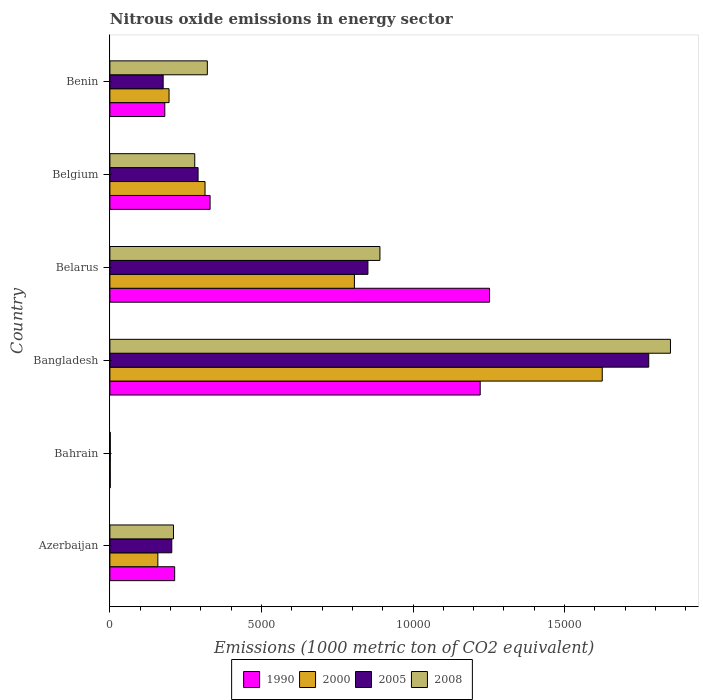How many groups of bars are there?
Provide a short and direct response. 6. Are the number of bars per tick equal to the number of legend labels?
Keep it short and to the point. Yes. Are the number of bars on each tick of the Y-axis equal?
Provide a succinct answer. Yes. What is the label of the 2nd group of bars from the top?
Offer a terse response. Belgium. In how many cases, is the number of bars for a given country not equal to the number of legend labels?
Your response must be concise. 0. What is the amount of nitrous oxide emitted in 2000 in Benin?
Make the answer very short. 1951.3. Across all countries, what is the maximum amount of nitrous oxide emitted in 2008?
Your answer should be compact. 1.85e+04. In which country was the amount of nitrous oxide emitted in 2005 minimum?
Provide a succinct answer. Bahrain. What is the total amount of nitrous oxide emitted in 2005 in the graph?
Make the answer very short. 3.30e+04. What is the difference between the amount of nitrous oxide emitted in 2008 in Bangladesh and that in Benin?
Give a very brief answer. 1.53e+04. What is the difference between the amount of nitrous oxide emitted in 2000 in Belarus and the amount of nitrous oxide emitted in 2008 in Benin?
Offer a very short reply. 4851.4. What is the average amount of nitrous oxide emitted in 2000 per country?
Your answer should be very brief. 5165.37. What is the difference between the amount of nitrous oxide emitted in 2000 and amount of nitrous oxide emitted in 2005 in Bangladesh?
Keep it short and to the point. -1533.4. What is the ratio of the amount of nitrous oxide emitted in 2008 in Azerbaijan to that in Bangladesh?
Provide a succinct answer. 0.11. Is the amount of nitrous oxide emitted in 2005 in Azerbaijan less than that in Bangladesh?
Keep it short and to the point. Yes. Is the difference between the amount of nitrous oxide emitted in 2000 in Bangladesh and Belarus greater than the difference between the amount of nitrous oxide emitted in 2005 in Bangladesh and Belarus?
Offer a very short reply. No. What is the difference between the highest and the second highest amount of nitrous oxide emitted in 2005?
Your answer should be compact. 9263.9. What is the difference between the highest and the lowest amount of nitrous oxide emitted in 2000?
Your answer should be compact. 1.62e+04. In how many countries, is the amount of nitrous oxide emitted in 1990 greater than the average amount of nitrous oxide emitted in 1990 taken over all countries?
Your answer should be compact. 2. What does the 3rd bar from the bottom in Azerbaijan represents?
Ensure brevity in your answer.  2005. How many countries are there in the graph?
Provide a short and direct response. 6. Does the graph contain any zero values?
Offer a very short reply. No. Does the graph contain grids?
Offer a terse response. No. Where does the legend appear in the graph?
Your response must be concise. Bottom center. How are the legend labels stacked?
Make the answer very short. Horizontal. What is the title of the graph?
Keep it short and to the point. Nitrous oxide emissions in energy sector. What is the label or title of the X-axis?
Give a very brief answer. Emissions (1000 metric ton of CO2 equivalent). What is the Emissions (1000 metric ton of CO2 equivalent) of 1990 in Azerbaijan?
Provide a short and direct response. 2137.1. What is the Emissions (1000 metric ton of CO2 equivalent) of 2000 in Azerbaijan?
Make the answer very short. 1582.1. What is the Emissions (1000 metric ton of CO2 equivalent) of 2005 in Azerbaijan?
Offer a very short reply. 2041.5. What is the Emissions (1000 metric ton of CO2 equivalent) in 2008 in Azerbaijan?
Provide a succinct answer. 2098. What is the Emissions (1000 metric ton of CO2 equivalent) of 2005 in Bahrain?
Offer a very short reply. 13.1. What is the Emissions (1000 metric ton of CO2 equivalent) in 1990 in Bangladesh?
Give a very brief answer. 1.22e+04. What is the Emissions (1000 metric ton of CO2 equivalent) in 2000 in Bangladesh?
Offer a terse response. 1.62e+04. What is the Emissions (1000 metric ton of CO2 equivalent) of 2005 in Bangladesh?
Offer a terse response. 1.78e+04. What is the Emissions (1000 metric ton of CO2 equivalent) in 2008 in Bangladesh?
Offer a terse response. 1.85e+04. What is the Emissions (1000 metric ton of CO2 equivalent) in 1990 in Belarus?
Provide a short and direct response. 1.25e+04. What is the Emissions (1000 metric ton of CO2 equivalent) of 2000 in Belarus?
Make the answer very short. 8066.2. What is the Emissions (1000 metric ton of CO2 equivalent) in 2005 in Belarus?
Your answer should be compact. 8511.9. What is the Emissions (1000 metric ton of CO2 equivalent) in 2008 in Belarus?
Provide a short and direct response. 8908.4. What is the Emissions (1000 metric ton of CO2 equivalent) in 1990 in Belgium?
Offer a very short reply. 3305.4. What is the Emissions (1000 metric ton of CO2 equivalent) in 2000 in Belgium?
Give a very brief answer. 3138.4. What is the Emissions (1000 metric ton of CO2 equivalent) of 2005 in Belgium?
Your answer should be very brief. 2909.4. What is the Emissions (1000 metric ton of CO2 equivalent) of 2008 in Belgium?
Give a very brief answer. 2799.3. What is the Emissions (1000 metric ton of CO2 equivalent) in 1990 in Benin?
Make the answer very short. 1811.1. What is the Emissions (1000 metric ton of CO2 equivalent) of 2000 in Benin?
Ensure brevity in your answer.  1951.3. What is the Emissions (1000 metric ton of CO2 equivalent) of 2005 in Benin?
Provide a succinct answer. 1757.4. What is the Emissions (1000 metric ton of CO2 equivalent) of 2008 in Benin?
Keep it short and to the point. 3214.8. Across all countries, what is the maximum Emissions (1000 metric ton of CO2 equivalent) in 1990?
Make the answer very short. 1.25e+04. Across all countries, what is the maximum Emissions (1000 metric ton of CO2 equivalent) in 2000?
Give a very brief answer. 1.62e+04. Across all countries, what is the maximum Emissions (1000 metric ton of CO2 equivalent) of 2005?
Your answer should be very brief. 1.78e+04. Across all countries, what is the maximum Emissions (1000 metric ton of CO2 equivalent) in 2008?
Your response must be concise. 1.85e+04. Across all countries, what is the minimum Emissions (1000 metric ton of CO2 equivalent) of 2000?
Your response must be concise. 11.8. Across all countries, what is the minimum Emissions (1000 metric ton of CO2 equivalent) in 2005?
Ensure brevity in your answer.  13.1. Across all countries, what is the minimum Emissions (1000 metric ton of CO2 equivalent) of 2008?
Provide a short and direct response. 13.6. What is the total Emissions (1000 metric ton of CO2 equivalent) of 1990 in the graph?
Make the answer very short. 3.20e+04. What is the total Emissions (1000 metric ton of CO2 equivalent) of 2000 in the graph?
Your answer should be compact. 3.10e+04. What is the total Emissions (1000 metric ton of CO2 equivalent) in 2005 in the graph?
Keep it short and to the point. 3.30e+04. What is the total Emissions (1000 metric ton of CO2 equivalent) of 2008 in the graph?
Offer a terse response. 3.55e+04. What is the difference between the Emissions (1000 metric ton of CO2 equivalent) of 1990 in Azerbaijan and that in Bahrain?
Ensure brevity in your answer.  2124.6. What is the difference between the Emissions (1000 metric ton of CO2 equivalent) in 2000 in Azerbaijan and that in Bahrain?
Offer a terse response. 1570.3. What is the difference between the Emissions (1000 metric ton of CO2 equivalent) of 2005 in Azerbaijan and that in Bahrain?
Provide a short and direct response. 2028.4. What is the difference between the Emissions (1000 metric ton of CO2 equivalent) in 2008 in Azerbaijan and that in Bahrain?
Ensure brevity in your answer.  2084.4. What is the difference between the Emissions (1000 metric ton of CO2 equivalent) of 1990 in Azerbaijan and that in Bangladesh?
Offer a very short reply. -1.01e+04. What is the difference between the Emissions (1000 metric ton of CO2 equivalent) of 2000 in Azerbaijan and that in Bangladesh?
Provide a succinct answer. -1.47e+04. What is the difference between the Emissions (1000 metric ton of CO2 equivalent) in 2005 in Azerbaijan and that in Bangladesh?
Provide a succinct answer. -1.57e+04. What is the difference between the Emissions (1000 metric ton of CO2 equivalent) in 2008 in Azerbaijan and that in Bangladesh?
Ensure brevity in your answer.  -1.64e+04. What is the difference between the Emissions (1000 metric ton of CO2 equivalent) in 1990 in Azerbaijan and that in Belarus?
Give a very brief answer. -1.04e+04. What is the difference between the Emissions (1000 metric ton of CO2 equivalent) of 2000 in Azerbaijan and that in Belarus?
Offer a very short reply. -6484.1. What is the difference between the Emissions (1000 metric ton of CO2 equivalent) in 2005 in Azerbaijan and that in Belarus?
Make the answer very short. -6470.4. What is the difference between the Emissions (1000 metric ton of CO2 equivalent) of 2008 in Azerbaijan and that in Belarus?
Your answer should be compact. -6810.4. What is the difference between the Emissions (1000 metric ton of CO2 equivalent) in 1990 in Azerbaijan and that in Belgium?
Offer a terse response. -1168.3. What is the difference between the Emissions (1000 metric ton of CO2 equivalent) of 2000 in Azerbaijan and that in Belgium?
Make the answer very short. -1556.3. What is the difference between the Emissions (1000 metric ton of CO2 equivalent) of 2005 in Azerbaijan and that in Belgium?
Your answer should be compact. -867.9. What is the difference between the Emissions (1000 metric ton of CO2 equivalent) in 2008 in Azerbaijan and that in Belgium?
Provide a short and direct response. -701.3. What is the difference between the Emissions (1000 metric ton of CO2 equivalent) of 1990 in Azerbaijan and that in Benin?
Make the answer very short. 326. What is the difference between the Emissions (1000 metric ton of CO2 equivalent) in 2000 in Azerbaijan and that in Benin?
Your answer should be very brief. -369.2. What is the difference between the Emissions (1000 metric ton of CO2 equivalent) in 2005 in Azerbaijan and that in Benin?
Provide a short and direct response. 284.1. What is the difference between the Emissions (1000 metric ton of CO2 equivalent) of 2008 in Azerbaijan and that in Benin?
Make the answer very short. -1116.8. What is the difference between the Emissions (1000 metric ton of CO2 equivalent) of 1990 in Bahrain and that in Bangladesh?
Give a very brief answer. -1.22e+04. What is the difference between the Emissions (1000 metric ton of CO2 equivalent) of 2000 in Bahrain and that in Bangladesh?
Ensure brevity in your answer.  -1.62e+04. What is the difference between the Emissions (1000 metric ton of CO2 equivalent) of 2005 in Bahrain and that in Bangladesh?
Provide a short and direct response. -1.78e+04. What is the difference between the Emissions (1000 metric ton of CO2 equivalent) in 2008 in Bahrain and that in Bangladesh?
Offer a terse response. -1.85e+04. What is the difference between the Emissions (1000 metric ton of CO2 equivalent) of 1990 in Bahrain and that in Belarus?
Ensure brevity in your answer.  -1.25e+04. What is the difference between the Emissions (1000 metric ton of CO2 equivalent) of 2000 in Bahrain and that in Belarus?
Provide a short and direct response. -8054.4. What is the difference between the Emissions (1000 metric ton of CO2 equivalent) of 2005 in Bahrain and that in Belarus?
Keep it short and to the point. -8498.8. What is the difference between the Emissions (1000 metric ton of CO2 equivalent) in 2008 in Bahrain and that in Belarus?
Provide a short and direct response. -8894.8. What is the difference between the Emissions (1000 metric ton of CO2 equivalent) in 1990 in Bahrain and that in Belgium?
Ensure brevity in your answer.  -3292.9. What is the difference between the Emissions (1000 metric ton of CO2 equivalent) of 2000 in Bahrain and that in Belgium?
Offer a terse response. -3126.6. What is the difference between the Emissions (1000 metric ton of CO2 equivalent) in 2005 in Bahrain and that in Belgium?
Ensure brevity in your answer.  -2896.3. What is the difference between the Emissions (1000 metric ton of CO2 equivalent) in 2008 in Bahrain and that in Belgium?
Your answer should be compact. -2785.7. What is the difference between the Emissions (1000 metric ton of CO2 equivalent) of 1990 in Bahrain and that in Benin?
Keep it short and to the point. -1798.6. What is the difference between the Emissions (1000 metric ton of CO2 equivalent) in 2000 in Bahrain and that in Benin?
Keep it short and to the point. -1939.5. What is the difference between the Emissions (1000 metric ton of CO2 equivalent) in 2005 in Bahrain and that in Benin?
Offer a very short reply. -1744.3. What is the difference between the Emissions (1000 metric ton of CO2 equivalent) of 2008 in Bahrain and that in Benin?
Your answer should be very brief. -3201.2. What is the difference between the Emissions (1000 metric ton of CO2 equivalent) in 1990 in Bangladesh and that in Belarus?
Give a very brief answer. -308.3. What is the difference between the Emissions (1000 metric ton of CO2 equivalent) in 2000 in Bangladesh and that in Belarus?
Your response must be concise. 8176.2. What is the difference between the Emissions (1000 metric ton of CO2 equivalent) in 2005 in Bangladesh and that in Belarus?
Keep it short and to the point. 9263.9. What is the difference between the Emissions (1000 metric ton of CO2 equivalent) in 2008 in Bangladesh and that in Belarus?
Offer a terse response. 9584.1. What is the difference between the Emissions (1000 metric ton of CO2 equivalent) in 1990 in Bangladesh and that in Belgium?
Give a very brief answer. 8910.9. What is the difference between the Emissions (1000 metric ton of CO2 equivalent) in 2000 in Bangladesh and that in Belgium?
Keep it short and to the point. 1.31e+04. What is the difference between the Emissions (1000 metric ton of CO2 equivalent) of 2005 in Bangladesh and that in Belgium?
Offer a terse response. 1.49e+04. What is the difference between the Emissions (1000 metric ton of CO2 equivalent) of 2008 in Bangladesh and that in Belgium?
Your response must be concise. 1.57e+04. What is the difference between the Emissions (1000 metric ton of CO2 equivalent) of 1990 in Bangladesh and that in Benin?
Your answer should be compact. 1.04e+04. What is the difference between the Emissions (1000 metric ton of CO2 equivalent) of 2000 in Bangladesh and that in Benin?
Provide a succinct answer. 1.43e+04. What is the difference between the Emissions (1000 metric ton of CO2 equivalent) of 2005 in Bangladesh and that in Benin?
Provide a short and direct response. 1.60e+04. What is the difference between the Emissions (1000 metric ton of CO2 equivalent) of 2008 in Bangladesh and that in Benin?
Your answer should be compact. 1.53e+04. What is the difference between the Emissions (1000 metric ton of CO2 equivalent) of 1990 in Belarus and that in Belgium?
Offer a very short reply. 9219.2. What is the difference between the Emissions (1000 metric ton of CO2 equivalent) of 2000 in Belarus and that in Belgium?
Offer a very short reply. 4927.8. What is the difference between the Emissions (1000 metric ton of CO2 equivalent) of 2005 in Belarus and that in Belgium?
Offer a terse response. 5602.5. What is the difference between the Emissions (1000 metric ton of CO2 equivalent) of 2008 in Belarus and that in Belgium?
Your answer should be compact. 6109.1. What is the difference between the Emissions (1000 metric ton of CO2 equivalent) of 1990 in Belarus and that in Benin?
Your response must be concise. 1.07e+04. What is the difference between the Emissions (1000 metric ton of CO2 equivalent) in 2000 in Belarus and that in Benin?
Make the answer very short. 6114.9. What is the difference between the Emissions (1000 metric ton of CO2 equivalent) in 2005 in Belarus and that in Benin?
Give a very brief answer. 6754.5. What is the difference between the Emissions (1000 metric ton of CO2 equivalent) of 2008 in Belarus and that in Benin?
Give a very brief answer. 5693.6. What is the difference between the Emissions (1000 metric ton of CO2 equivalent) in 1990 in Belgium and that in Benin?
Your response must be concise. 1494.3. What is the difference between the Emissions (1000 metric ton of CO2 equivalent) of 2000 in Belgium and that in Benin?
Ensure brevity in your answer.  1187.1. What is the difference between the Emissions (1000 metric ton of CO2 equivalent) in 2005 in Belgium and that in Benin?
Ensure brevity in your answer.  1152. What is the difference between the Emissions (1000 metric ton of CO2 equivalent) of 2008 in Belgium and that in Benin?
Give a very brief answer. -415.5. What is the difference between the Emissions (1000 metric ton of CO2 equivalent) of 1990 in Azerbaijan and the Emissions (1000 metric ton of CO2 equivalent) of 2000 in Bahrain?
Keep it short and to the point. 2125.3. What is the difference between the Emissions (1000 metric ton of CO2 equivalent) in 1990 in Azerbaijan and the Emissions (1000 metric ton of CO2 equivalent) in 2005 in Bahrain?
Keep it short and to the point. 2124. What is the difference between the Emissions (1000 metric ton of CO2 equivalent) in 1990 in Azerbaijan and the Emissions (1000 metric ton of CO2 equivalent) in 2008 in Bahrain?
Offer a very short reply. 2123.5. What is the difference between the Emissions (1000 metric ton of CO2 equivalent) of 2000 in Azerbaijan and the Emissions (1000 metric ton of CO2 equivalent) of 2005 in Bahrain?
Keep it short and to the point. 1569. What is the difference between the Emissions (1000 metric ton of CO2 equivalent) of 2000 in Azerbaijan and the Emissions (1000 metric ton of CO2 equivalent) of 2008 in Bahrain?
Ensure brevity in your answer.  1568.5. What is the difference between the Emissions (1000 metric ton of CO2 equivalent) of 2005 in Azerbaijan and the Emissions (1000 metric ton of CO2 equivalent) of 2008 in Bahrain?
Keep it short and to the point. 2027.9. What is the difference between the Emissions (1000 metric ton of CO2 equivalent) in 1990 in Azerbaijan and the Emissions (1000 metric ton of CO2 equivalent) in 2000 in Bangladesh?
Provide a succinct answer. -1.41e+04. What is the difference between the Emissions (1000 metric ton of CO2 equivalent) in 1990 in Azerbaijan and the Emissions (1000 metric ton of CO2 equivalent) in 2005 in Bangladesh?
Provide a short and direct response. -1.56e+04. What is the difference between the Emissions (1000 metric ton of CO2 equivalent) in 1990 in Azerbaijan and the Emissions (1000 metric ton of CO2 equivalent) in 2008 in Bangladesh?
Keep it short and to the point. -1.64e+04. What is the difference between the Emissions (1000 metric ton of CO2 equivalent) of 2000 in Azerbaijan and the Emissions (1000 metric ton of CO2 equivalent) of 2005 in Bangladesh?
Your answer should be compact. -1.62e+04. What is the difference between the Emissions (1000 metric ton of CO2 equivalent) in 2000 in Azerbaijan and the Emissions (1000 metric ton of CO2 equivalent) in 2008 in Bangladesh?
Provide a succinct answer. -1.69e+04. What is the difference between the Emissions (1000 metric ton of CO2 equivalent) of 2005 in Azerbaijan and the Emissions (1000 metric ton of CO2 equivalent) of 2008 in Bangladesh?
Your answer should be compact. -1.65e+04. What is the difference between the Emissions (1000 metric ton of CO2 equivalent) of 1990 in Azerbaijan and the Emissions (1000 metric ton of CO2 equivalent) of 2000 in Belarus?
Keep it short and to the point. -5929.1. What is the difference between the Emissions (1000 metric ton of CO2 equivalent) in 1990 in Azerbaijan and the Emissions (1000 metric ton of CO2 equivalent) in 2005 in Belarus?
Provide a succinct answer. -6374.8. What is the difference between the Emissions (1000 metric ton of CO2 equivalent) in 1990 in Azerbaijan and the Emissions (1000 metric ton of CO2 equivalent) in 2008 in Belarus?
Ensure brevity in your answer.  -6771.3. What is the difference between the Emissions (1000 metric ton of CO2 equivalent) of 2000 in Azerbaijan and the Emissions (1000 metric ton of CO2 equivalent) of 2005 in Belarus?
Provide a short and direct response. -6929.8. What is the difference between the Emissions (1000 metric ton of CO2 equivalent) of 2000 in Azerbaijan and the Emissions (1000 metric ton of CO2 equivalent) of 2008 in Belarus?
Provide a succinct answer. -7326.3. What is the difference between the Emissions (1000 metric ton of CO2 equivalent) in 2005 in Azerbaijan and the Emissions (1000 metric ton of CO2 equivalent) in 2008 in Belarus?
Keep it short and to the point. -6866.9. What is the difference between the Emissions (1000 metric ton of CO2 equivalent) in 1990 in Azerbaijan and the Emissions (1000 metric ton of CO2 equivalent) in 2000 in Belgium?
Offer a terse response. -1001.3. What is the difference between the Emissions (1000 metric ton of CO2 equivalent) in 1990 in Azerbaijan and the Emissions (1000 metric ton of CO2 equivalent) in 2005 in Belgium?
Ensure brevity in your answer.  -772.3. What is the difference between the Emissions (1000 metric ton of CO2 equivalent) in 1990 in Azerbaijan and the Emissions (1000 metric ton of CO2 equivalent) in 2008 in Belgium?
Ensure brevity in your answer.  -662.2. What is the difference between the Emissions (1000 metric ton of CO2 equivalent) in 2000 in Azerbaijan and the Emissions (1000 metric ton of CO2 equivalent) in 2005 in Belgium?
Offer a terse response. -1327.3. What is the difference between the Emissions (1000 metric ton of CO2 equivalent) in 2000 in Azerbaijan and the Emissions (1000 metric ton of CO2 equivalent) in 2008 in Belgium?
Keep it short and to the point. -1217.2. What is the difference between the Emissions (1000 metric ton of CO2 equivalent) in 2005 in Azerbaijan and the Emissions (1000 metric ton of CO2 equivalent) in 2008 in Belgium?
Offer a terse response. -757.8. What is the difference between the Emissions (1000 metric ton of CO2 equivalent) in 1990 in Azerbaijan and the Emissions (1000 metric ton of CO2 equivalent) in 2000 in Benin?
Make the answer very short. 185.8. What is the difference between the Emissions (1000 metric ton of CO2 equivalent) of 1990 in Azerbaijan and the Emissions (1000 metric ton of CO2 equivalent) of 2005 in Benin?
Ensure brevity in your answer.  379.7. What is the difference between the Emissions (1000 metric ton of CO2 equivalent) of 1990 in Azerbaijan and the Emissions (1000 metric ton of CO2 equivalent) of 2008 in Benin?
Provide a short and direct response. -1077.7. What is the difference between the Emissions (1000 metric ton of CO2 equivalent) in 2000 in Azerbaijan and the Emissions (1000 metric ton of CO2 equivalent) in 2005 in Benin?
Make the answer very short. -175.3. What is the difference between the Emissions (1000 metric ton of CO2 equivalent) in 2000 in Azerbaijan and the Emissions (1000 metric ton of CO2 equivalent) in 2008 in Benin?
Keep it short and to the point. -1632.7. What is the difference between the Emissions (1000 metric ton of CO2 equivalent) in 2005 in Azerbaijan and the Emissions (1000 metric ton of CO2 equivalent) in 2008 in Benin?
Your answer should be compact. -1173.3. What is the difference between the Emissions (1000 metric ton of CO2 equivalent) in 1990 in Bahrain and the Emissions (1000 metric ton of CO2 equivalent) in 2000 in Bangladesh?
Ensure brevity in your answer.  -1.62e+04. What is the difference between the Emissions (1000 metric ton of CO2 equivalent) of 1990 in Bahrain and the Emissions (1000 metric ton of CO2 equivalent) of 2005 in Bangladesh?
Give a very brief answer. -1.78e+04. What is the difference between the Emissions (1000 metric ton of CO2 equivalent) of 1990 in Bahrain and the Emissions (1000 metric ton of CO2 equivalent) of 2008 in Bangladesh?
Provide a short and direct response. -1.85e+04. What is the difference between the Emissions (1000 metric ton of CO2 equivalent) of 2000 in Bahrain and the Emissions (1000 metric ton of CO2 equivalent) of 2005 in Bangladesh?
Make the answer very short. -1.78e+04. What is the difference between the Emissions (1000 metric ton of CO2 equivalent) of 2000 in Bahrain and the Emissions (1000 metric ton of CO2 equivalent) of 2008 in Bangladesh?
Provide a succinct answer. -1.85e+04. What is the difference between the Emissions (1000 metric ton of CO2 equivalent) of 2005 in Bahrain and the Emissions (1000 metric ton of CO2 equivalent) of 2008 in Bangladesh?
Keep it short and to the point. -1.85e+04. What is the difference between the Emissions (1000 metric ton of CO2 equivalent) of 1990 in Bahrain and the Emissions (1000 metric ton of CO2 equivalent) of 2000 in Belarus?
Make the answer very short. -8053.7. What is the difference between the Emissions (1000 metric ton of CO2 equivalent) in 1990 in Bahrain and the Emissions (1000 metric ton of CO2 equivalent) in 2005 in Belarus?
Your response must be concise. -8499.4. What is the difference between the Emissions (1000 metric ton of CO2 equivalent) in 1990 in Bahrain and the Emissions (1000 metric ton of CO2 equivalent) in 2008 in Belarus?
Your answer should be compact. -8895.9. What is the difference between the Emissions (1000 metric ton of CO2 equivalent) of 2000 in Bahrain and the Emissions (1000 metric ton of CO2 equivalent) of 2005 in Belarus?
Ensure brevity in your answer.  -8500.1. What is the difference between the Emissions (1000 metric ton of CO2 equivalent) of 2000 in Bahrain and the Emissions (1000 metric ton of CO2 equivalent) of 2008 in Belarus?
Make the answer very short. -8896.6. What is the difference between the Emissions (1000 metric ton of CO2 equivalent) in 2005 in Bahrain and the Emissions (1000 metric ton of CO2 equivalent) in 2008 in Belarus?
Provide a succinct answer. -8895.3. What is the difference between the Emissions (1000 metric ton of CO2 equivalent) in 1990 in Bahrain and the Emissions (1000 metric ton of CO2 equivalent) in 2000 in Belgium?
Make the answer very short. -3125.9. What is the difference between the Emissions (1000 metric ton of CO2 equivalent) in 1990 in Bahrain and the Emissions (1000 metric ton of CO2 equivalent) in 2005 in Belgium?
Your answer should be very brief. -2896.9. What is the difference between the Emissions (1000 metric ton of CO2 equivalent) in 1990 in Bahrain and the Emissions (1000 metric ton of CO2 equivalent) in 2008 in Belgium?
Ensure brevity in your answer.  -2786.8. What is the difference between the Emissions (1000 metric ton of CO2 equivalent) of 2000 in Bahrain and the Emissions (1000 metric ton of CO2 equivalent) of 2005 in Belgium?
Offer a very short reply. -2897.6. What is the difference between the Emissions (1000 metric ton of CO2 equivalent) of 2000 in Bahrain and the Emissions (1000 metric ton of CO2 equivalent) of 2008 in Belgium?
Keep it short and to the point. -2787.5. What is the difference between the Emissions (1000 metric ton of CO2 equivalent) in 2005 in Bahrain and the Emissions (1000 metric ton of CO2 equivalent) in 2008 in Belgium?
Provide a succinct answer. -2786.2. What is the difference between the Emissions (1000 metric ton of CO2 equivalent) in 1990 in Bahrain and the Emissions (1000 metric ton of CO2 equivalent) in 2000 in Benin?
Provide a succinct answer. -1938.8. What is the difference between the Emissions (1000 metric ton of CO2 equivalent) in 1990 in Bahrain and the Emissions (1000 metric ton of CO2 equivalent) in 2005 in Benin?
Give a very brief answer. -1744.9. What is the difference between the Emissions (1000 metric ton of CO2 equivalent) of 1990 in Bahrain and the Emissions (1000 metric ton of CO2 equivalent) of 2008 in Benin?
Provide a succinct answer. -3202.3. What is the difference between the Emissions (1000 metric ton of CO2 equivalent) of 2000 in Bahrain and the Emissions (1000 metric ton of CO2 equivalent) of 2005 in Benin?
Make the answer very short. -1745.6. What is the difference between the Emissions (1000 metric ton of CO2 equivalent) in 2000 in Bahrain and the Emissions (1000 metric ton of CO2 equivalent) in 2008 in Benin?
Offer a very short reply. -3203. What is the difference between the Emissions (1000 metric ton of CO2 equivalent) of 2005 in Bahrain and the Emissions (1000 metric ton of CO2 equivalent) of 2008 in Benin?
Your answer should be very brief. -3201.7. What is the difference between the Emissions (1000 metric ton of CO2 equivalent) of 1990 in Bangladesh and the Emissions (1000 metric ton of CO2 equivalent) of 2000 in Belarus?
Your response must be concise. 4150.1. What is the difference between the Emissions (1000 metric ton of CO2 equivalent) in 1990 in Bangladesh and the Emissions (1000 metric ton of CO2 equivalent) in 2005 in Belarus?
Make the answer very short. 3704.4. What is the difference between the Emissions (1000 metric ton of CO2 equivalent) of 1990 in Bangladesh and the Emissions (1000 metric ton of CO2 equivalent) of 2008 in Belarus?
Make the answer very short. 3307.9. What is the difference between the Emissions (1000 metric ton of CO2 equivalent) of 2000 in Bangladesh and the Emissions (1000 metric ton of CO2 equivalent) of 2005 in Belarus?
Your answer should be very brief. 7730.5. What is the difference between the Emissions (1000 metric ton of CO2 equivalent) in 2000 in Bangladesh and the Emissions (1000 metric ton of CO2 equivalent) in 2008 in Belarus?
Keep it short and to the point. 7334. What is the difference between the Emissions (1000 metric ton of CO2 equivalent) of 2005 in Bangladesh and the Emissions (1000 metric ton of CO2 equivalent) of 2008 in Belarus?
Provide a short and direct response. 8867.4. What is the difference between the Emissions (1000 metric ton of CO2 equivalent) of 1990 in Bangladesh and the Emissions (1000 metric ton of CO2 equivalent) of 2000 in Belgium?
Give a very brief answer. 9077.9. What is the difference between the Emissions (1000 metric ton of CO2 equivalent) in 1990 in Bangladesh and the Emissions (1000 metric ton of CO2 equivalent) in 2005 in Belgium?
Your answer should be very brief. 9306.9. What is the difference between the Emissions (1000 metric ton of CO2 equivalent) in 1990 in Bangladesh and the Emissions (1000 metric ton of CO2 equivalent) in 2008 in Belgium?
Provide a short and direct response. 9417. What is the difference between the Emissions (1000 metric ton of CO2 equivalent) in 2000 in Bangladesh and the Emissions (1000 metric ton of CO2 equivalent) in 2005 in Belgium?
Your answer should be very brief. 1.33e+04. What is the difference between the Emissions (1000 metric ton of CO2 equivalent) in 2000 in Bangladesh and the Emissions (1000 metric ton of CO2 equivalent) in 2008 in Belgium?
Your response must be concise. 1.34e+04. What is the difference between the Emissions (1000 metric ton of CO2 equivalent) of 2005 in Bangladesh and the Emissions (1000 metric ton of CO2 equivalent) of 2008 in Belgium?
Provide a short and direct response. 1.50e+04. What is the difference between the Emissions (1000 metric ton of CO2 equivalent) in 1990 in Bangladesh and the Emissions (1000 metric ton of CO2 equivalent) in 2000 in Benin?
Ensure brevity in your answer.  1.03e+04. What is the difference between the Emissions (1000 metric ton of CO2 equivalent) in 1990 in Bangladesh and the Emissions (1000 metric ton of CO2 equivalent) in 2005 in Benin?
Provide a short and direct response. 1.05e+04. What is the difference between the Emissions (1000 metric ton of CO2 equivalent) in 1990 in Bangladesh and the Emissions (1000 metric ton of CO2 equivalent) in 2008 in Benin?
Ensure brevity in your answer.  9001.5. What is the difference between the Emissions (1000 metric ton of CO2 equivalent) of 2000 in Bangladesh and the Emissions (1000 metric ton of CO2 equivalent) of 2005 in Benin?
Provide a succinct answer. 1.45e+04. What is the difference between the Emissions (1000 metric ton of CO2 equivalent) of 2000 in Bangladesh and the Emissions (1000 metric ton of CO2 equivalent) of 2008 in Benin?
Offer a very short reply. 1.30e+04. What is the difference between the Emissions (1000 metric ton of CO2 equivalent) of 2005 in Bangladesh and the Emissions (1000 metric ton of CO2 equivalent) of 2008 in Benin?
Make the answer very short. 1.46e+04. What is the difference between the Emissions (1000 metric ton of CO2 equivalent) in 1990 in Belarus and the Emissions (1000 metric ton of CO2 equivalent) in 2000 in Belgium?
Your answer should be very brief. 9386.2. What is the difference between the Emissions (1000 metric ton of CO2 equivalent) of 1990 in Belarus and the Emissions (1000 metric ton of CO2 equivalent) of 2005 in Belgium?
Keep it short and to the point. 9615.2. What is the difference between the Emissions (1000 metric ton of CO2 equivalent) of 1990 in Belarus and the Emissions (1000 metric ton of CO2 equivalent) of 2008 in Belgium?
Provide a short and direct response. 9725.3. What is the difference between the Emissions (1000 metric ton of CO2 equivalent) of 2000 in Belarus and the Emissions (1000 metric ton of CO2 equivalent) of 2005 in Belgium?
Your answer should be very brief. 5156.8. What is the difference between the Emissions (1000 metric ton of CO2 equivalent) of 2000 in Belarus and the Emissions (1000 metric ton of CO2 equivalent) of 2008 in Belgium?
Your response must be concise. 5266.9. What is the difference between the Emissions (1000 metric ton of CO2 equivalent) of 2005 in Belarus and the Emissions (1000 metric ton of CO2 equivalent) of 2008 in Belgium?
Offer a terse response. 5712.6. What is the difference between the Emissions (1000 metric ton of CO2 equivalent) in 1990 in Belarus and the Emissions (1000 metric ton of CO2 equivalent) in 2000 in Benin?
Provide a succinct answer. 1.06e+04. What is the difference between the Emissions (1000 metric ton of CO2 equivalent) in 1990 in Belarus and the Emissions (1000 metric ton of CO2 equivalent) in 2005 in Benin?
Offer a terse response. 1.08e+04. What is the difference between the Emissions (1000 metric ton of CO2 equivalent) of 1990 in Belarus and the Emissions (1000 metric ton of CO2 equivalent) of 2008 in Benin?
Make the answer very short. 9309.8. What is the difference between the Emissions (1000 metric ton of CO2 equivalent) in 2000 in Belarus and the Emissions (1000 metric ton of CO2 equivalent) in 2005 in Benin?
Provide a succinct answer. 6308.8. What is the difference between the Emissions (1000 metric ton of CO2 equivalent) of 2000 in Belarus and the Emissions (1000 metric ton of CO2 equivalent) of 2008 in Benin?
Your response must be concise. 4851.4. What is the difference between the Emissions (1000 metric ton of CO2 equivalent) in 2005 in Belarus and the Emissions (1000 metric ton of CO2 equivalent) in 2008 in Benin?
Your answer should be compact. 5297.1. What is the difference between the Emissions (1000 metric ton of CO2 equivalent) in 1990 in Belgium and the Emissions (1000 metric ton of CO2 equivalent) in 2000 in Benin?
Your answer should be very brief. 1354.1. What is the difference between the Emissions (1000 metric ton of CO2 equivalent) of 1990 in Belgium and the Emissions (1000 metric ton of CO2 equivalent) of 2005 in Benin?
Your answer should be compact. 1548. What is the difference between the Emissions (1000 metric ton of CO2 equivalent) in 1990 in Belgium and the Emissions (1000 metric ton of CO2 equivalent) in 2008 in Benin?
Your answer should be very brief. 90.6. What is the difference between the Emissions (1000 metric ton of CO2 equivalent) in 2000 in Belgium and the Emissions (1000 metric ton of CO2 equivalent) in 2005 in Benin?
Offer a terse response. 1381. What is the difference between the Emissions (1000 metric ton of CO2 equivalent) in 2000 in Belgium and the Emissions (1000 metric ton of CO2 equivalent) in 2008 in Benin?
Make the answer very short. -76.4. What is the difference between the Emissions (1000 metric ton of CO2 equivalent) of 2005 in Belgium and the Emissions (1000 metric ton of CO2 equivalent) of 2008 in Benin?
Give a very brief answer. -305.4. What is the average Emissions (1000 metric ton of CO2 equivalent) in 1990 per country?
Your answer should be compact. 5334.5. What is the average Emissions (1000 metric ton of CO2 equivalent) of 2000 per country?
Ensure brevity in your answer.  5165.37. What is the average Emissions (1000 metric ton of CO2 equivalent) in 2005 per country?
Make the answer very short. 5501.52. What is the average Emissions (1000 metric ton of CO2 equivalent) in 2008 per country?
Keep it short and to the point. 5921.1. What is the difference between the Emissions (1000 metric ton of CO2 equivalent) in 1990 and Emissions (1000 metric ton of CO2 equivalent) in 2000 in Azerbaijan?
Offer a very short reply. 555. What is the difference between the Emissions (1000 metric ton of CO2 equivalent) of 1990 and Emissions (1000 metric ton of CO2 equivalent) of 2005 in Azerbaijan?
Offer a terse response. 95.6. What is the difference between the Emissions (1000 metric ton of CO2 equivalent) in 1990 and Emissions (1000 metric ton of CO2 equivalent) in 2008 in Azerbaijan?
Ensure brevity in your answer.  39.1. What is the difference between the Emissions (1000 metric ton of CO2 equivalent) of 2000 and Emissions (1000 metric ton of CO2 equivalent) of 2005 in Azerbaijan?
Offer a terse response. -459.4. What is the difference between the Emissions (1000 metric ton of CO2 equivalent) of 2000 and Emissions (1000 metric ton of CO2 equivalent) of 2008 in Azerbaijan?
Provide a succinct answer. -515.9. What is the difference between the Emissions (1000 metric ton of CO2 equivalent) of 2005 and Emissions (1000 metric ton of CO2 equivalent) of 2008 in Azerbaijan?
Keep it short and to the point. -56.5. What is the difference between the Emissions (1000 metric ton of CO2 equivalent) in 1990 and Emissions (1000 metric ton of CO2 equivalent) in 2005 in Bahrain?
Make the answer very short. -0.6. What is the difference between the Emissions (1000 metric ton of CO2 equivalent) of 2005 and Emissions (1000 metric ton of CO2 equivalent) of 2008 in Bahrain?
Provide a short and direct response. -0.5. What is the difference between the Emissions (1000 metric ton of CO2 equivalent) of 1990 and Emissions (1000 metric ton of CO2 equivalent) of 2000 in Bangladesh?
Your response must be concise. -4026.1. What is the difference between the Emissions (1000 metric ton of CO2 equivalent) of 1990 and Emissions (1000 metric ton of CO2 equivalent) of 2005 in Bangladesh?
Provide a succinct answer. -5559.5. What is the difference between the Emissions (1000 metric ton of CO2 equivalent) of 1990 and Emissions (1000 metric ton of CO2 equivalent) of 2008 in Bangladesh?
Offer a very short reply. -6276.2. What is the difference between the Emissions (1000 metric ton of CO2 equivalent) of 2000 and Emissions (1000 metric ton of CO2 equivalent) of 2005 in Bangladesh?
Provide a succinct answer. -1533.4. What is the difference between the Emissions (1000 metric ton of CO2 equivalent) of 2000 and Emissions (1000 metric ton of CO2 equivalent) of 2008 in Bangladesh?
Give a very brief answer. -2250.1. What is the difference between the Emissions (1000 metric ton of CO2 equivalent) of 2005 and Emissions (1000 metric ton of CO2 equivalent) of 2008 in Bangladesh?
Provide a short and direct response. -716.7. What is the difference between the Emissions (1000 metric ton of CO2 equivalent) of 1990 and Emissions (1000 metric ton of CO2 equivalent) of 2000 in Belarus?
Make the answer very short. 4458.4. What is the difference between the Emissions (1000 metric ton of CO2 equivalent) of 1990 and Emissions (1000 metric ton of CO2 equivalent) of 2005 in Belarus?
Your response must be concise. 4012.7. What is the difference between the Emissions (1000 metric ton of CO2 equivalent) in 1990 and Emissions (1000 metric ton of CO2 equivalent) in 2008 in Belarus?
Offer a terse response. 3616.2. What is the difference between the Emissions (1000 metric ton of CO2 equivalent) in 2000 and Emissions (1000 metric ton of CO2 equivalent) in 2005 in Belarus?
Offer a very short reply. -445.7. What is the difference between the Emissions (1000 metric ton of CO2 equivalent) of 2000 and Emissions (1000 metric ton of CO2 equivalent) of 2008 in Belarus?
Ensure brevity in your answer.  -842.2. What is the difference between the Emissions (1000 metric ton of CO2 equivalent) of 2005 and Emissions (1000 metric ton of CO2 equivalent) of 2008 in Belarus?
Offer a very short reply. -396.5. What is the difference between the Emissions (1000 metric ton of CO2 equivalent) in 1990 and Emissions (1000 metric ton of CO2 equivalent) in 2000 in Belgium?
Keep it short and to the point. 167. What is the difference between the Emissions (1000 metric ton of CO2 equivalent) in 1990 and Emissions (1000 metric ton of CO2 equivalent) in 2005 in Belgium?
Provide a short and direct response. 396. What is the difference between the Emissions (1000 metric ton of CO2 equivalent) in 1990 and Emissions (1000 metric ton of CO2 equivalent) in 2008 in Belgium?
Make the answer very short. 506.1. What is the difference between the Emissions (1000 metric ton of CO2 equivalent) of 2000 and Emissions (1000 metric ton of CO2 equivalent) of 2005 in Belgium?
Provide a short and direct response. 229. What is the difference between the Emissions (1000 metric ton of CO2 equivalent) in 2000 and Emissions (1000 metric ton of CO2 equivalent) in 2008 in Belgium?
Your answer should be very brief. 339.1. What is the difference between the Emissions (1000 metric ton of CO2 equivalent) in 2005 and Emissions (1000 metric ton of CO2 equivalent) in 2008 in Belgium?
Give a very brief answer. 110.1. What is the difference between the Emissions (1000 metric ton of CO2 equivalent) in 1990 and Emissions (1000 metric ton of CO2 equivalent) in 2000 in Benin?
Provide a succinct answer. -140.2. What is the difference between the Emissions (1000 metric ton of CO2 equivalent) of 1990 and Emissions (1000 metric ton of CO2 equivalent) of 2005 in Benin?
Provide a short and direct response. 53.7. What is the difference between the Emissions (1000 metric ton of CO2 equivalent) in 1990 and Emissions (1000 metric ton of CO2 equivalent) in 2008 in Benin?
Your answer should be very brief. -1403.7. What is the difference between the Emissions (1000 metric ton of CO2 equivalent) of 2000 and Emissions (1000 metric ton of CO2 equivalent) of 2005 in Benin?
Offer a terse response. 193.9. What is the difference between the Emissions (1000 metric ton of CO2 equivalent) in 2000 and Emissions (1000 metric ton of CO2 equivalent) in 2008 in Benin?
Your response must be concise. -1263.5. What is the difference between the Emissions (1000 metric ton of CO2 equivalent) in 2005 and Emissions (1000 metric ton of CO2 equivalent) in 2008 in Benin?
Your answer should be compact. -1457.4. What is the ratio of the Emissions (1000 metric ton of CO2 equivalent) of 1990 in Azerbaijan to that in Bahrain?
Offer a terse response. 170.97. What is the ratio of the Emissions (1000 metric ton of CO2 equivalent) of 2000 in Azerbaijan to that in Bahrain?
Make the answer very short. 134.08. What is the ratio of the Emissions (1000 metric ton of CO2 equivalent) of 2005 in Azerbaijan to that in Bahrain?
Your answer should be very brief. 155.84. What is the ratio of the Emissions (1000 metric ton of CO2 equivalent) of 2008 in Azerbaijan to that in Bahrain?
Your answer should be compact. 154.26. What is the ratio of the Emissions (1000 metric ton of CO2 equivalent) in 1990 in Azerbaijan to that in Bangladesh?
Provide a succinct answer. 0.17. What is the ratio of the Emissions (1000 metric ton of CO2 equivalent) of 2000 in Azerbaijan to that in Bangladesh?
Provide a short and direct response. 0.1. What is the ratio of the Emissions (1000 metric ton of CO2 equivalent) of 2005 in Azerbaijan to that in Bangladesh?
Provide a succinct answer. 0.11. What is the ratio of the Emissions (1000 metric ton of CO2 equivalent) in 2008 in Azerbaijan to that in Bangladesh?
Make the answer very short. 0.11. What is the ratio of the Emissions (1000 metric ton of CO2 equivalent) in 1990 in Azerbaijan to that in Belarus?
Offer a terse response. 0.17. What is the ratio of the Emissions (1000 metric ton of CO2 equivalent) in 2000 in Azerbaijan to that in Belarus?
Provide a succinct answer. 0.2. What is the ratio of the Emissions (1000 metric ton of CO2 equivalent) in 2005 in Azerbaijan to that in Belarus?
Offer a very short reply. 0.24. What is the ratio of the Emissions (1000 metric ton of CO2 equivalent) of 2008 in Azerbaijan to that in Belarus?
Ensure brevity in your answer.  0.24. What is the ratio of the Emissions (1000 metric ton of CO2 equivalent) of 1990 in Azerbaijan to that in Belgium?
Provide a short and direct response. 0.65. What is the ratio of the Emissions (1000 metric ton of CO2 equivalent) of 2000 in Azerbaijan to that in Belgium?
Provide a succinct answer. 0.5. What is the ratio of the Emissions (1000 metric ton of CO2 equivalent) of 2005 in Azerbaijan to that in Belgium?
Offer a terse response. 0.7. What is the ratio of the Emissions (1000 metric ton of CO2 equivalent) of 2008 in Azerbaijan to that in Belgium?
Offer a terse response. 0.75. What is the ratio of the Emissions (1000 metric ton of CO2 equivalent) in 1990 in Azerbaijan to that in Benin?
Make the answer very short. 1.18. What is the ratio of the Emissions (1000 metric ton of CO2 equivalent) in 2000 in Azerbaijan to that in Benin?
Provide a succinct answer. 0.81. What is the ratio of the Emissions (1000 metric ton of CO2 equivalent) in 2005 in Azerbaijan to that in Benin?
Provide a succinct answer. 1.16. What is the ratio of the Emissions (1000 metric ton of CO2 equivalent) of 2008 in Azerbaijan to that in Benin?
Your answer should be compact. 0.65. What is the ratio of the Emissions (1000 metric ton of CO2 equivalent) of 2000 in Bahrain to that in Bangladesh?
Your answer should be compact. 0. What is the ratio of the Emissions (1000 metric ton of CO2 equivalent) in 2005 in Bahrain to that in Bangladesh?
Your answer should be compact. 0. What is the ratio of the Emissions (1000 metric ton of CO2 equivalent) in 2008 in Bahrain to that in Bangladesh?
Offer a very short reply. 0. What is the ratio of the Emissions (1000 metric ton of CO2 equivalent) of 1990 in Bahrain to that in Belarus?
Your response must be concise. 0. What is the ratio of the Emissions (1000 metric ton of CO2 equivalent) in 2000 in Bahrain to that in Belarus?
Your answer should be compact. 0. What is the ratio of the Emissions (1000 metric ton of CO2 equivalent) in 2005 in Bahrain to that in Belarus?
Keep it short and to the point. 0. What is the ratio of the Emissions (1000 metric ton of CO2 equivalent) of 2008 in Bahrain to that in Belarus?
Make the answer very short. 0. What is the ratio of the Emissions (1000 metric ton of CO2 equivalent) of 1990 in Bahrain to that in Belgium?
Your answer should be compact. 0. What is the ratio of the Emissions (1000 metric ton of CO2 equivalent) in 2000 in Bahrain to that in Belgium?
Your answer should be compact. 0. What is the ratio of the Emissions (1000 metric ton of CO2 equivalent) of 2005 in Bahrain to that in Belgium?
Make the answer very short. 0. What is the ratio of the Emissions (1000 metric ton of CO2 equivalent) of 2008 in Bahrain to that in Belgium?
Provide a succinct answer. 0. What is the ratio of the Emissions (1000 metric ton of CO2 equivalent) of 1990 in Bahrain to that in Benin?
Offer a terse response. 0.01. What is the ratio of the Emissions (1000 metric ton of CO2 equivalent) of 2000 in Bahrain to that in Benin?
Keep it short and to the point. 0.01. What is the ratio of the Emissions (1000 metric ton of CO2 equivalent) in 2005 in Bahrain to that in Benin?
Give a very brief answer. 0.01. What is the ratio of the Emissions (1000 metric ton of CO2 equivalent) of 2008 in Bahrain to that in Benin?
Your answer should be very brief. 0. What is the ratio of the Emissions (1000 metric ton of CO2 equivalent) of 1990 in Bangladesh to that in Belarus?
Offer a very short reply. 0.98. What is the ratio of the Emissions (1000 metric ton of CO2 equivalent) of 2000 in Bangladesh to that in Belarus?
Give a very brief answer. 2.01. What is the ratio of the Emissions (1000 metric ton of CO2 equivalent) in 2005 in Bangladesh to that in Belarus?
Provide a succinct answer. 2.09. What is the ratio of the Emissions (1000 metric ton of CO2 equivalent) of 2008 in Bangladesh to that in Belarus?
Make the answer very short. 2.08. What is the ratio of the Emissions (1000 metric ton of CO2 equivalent) of 1990 in Bangladesh to that in Belgium?
Your answer should be compact. 3.7. What is the ratio of the Emissions (1000 metric ton of CO2 equivalent) in 2000 in Bangladesh to that in Belgium?
Your answer should be very brief. 5.18. What is the ratio of the Emissions (1000 metric ton of CO2 equivalent) of 2005 in Bangladesh to that in Belgium?
Your answer should be very brief. 6.11. What is the ratio of the Emissions (1000 metric ton of CO2 equivalent) of 2008 in Bangladesh to that in Belgium?
Provide a succinct answer. 6.61. What is the ratio of the Emissions (1000 metric ton of CO2 equivalent) in 1990 in Bangladesh to that in Benin?
Your answer should be very brief. 6.75. What is the ratio of the Emissions (1000 metric ton of CO2 equivalent) in 2000 in Bangladesh to that in Benin?
Provide a short and direct response. 8.32. What is the ratio of the Emissions (1000 metric ton of CO2 equivalent) in 2005 in Bangladesh to that in Benin?
Your answer should be very brief. 10.11. What is the ratio of the Emissions (1000 metric ton of CO2 equivalent) of 2008 in Bangladesh to that in Benin?
Ensure brevity in your answer.  5.75. What is the ratio of the Emissions (1000 metric ton of CO2 equivalent) in 1990 in Belarus to that in Belgium?
Provide a succinct answer. 3.79. What is the ratio of the Emissions (1000 metric ton of CO2 equivalent) of 2000 in Belarus to that in Belgium?
Provide a succinct answer. 2.57. What is the ratio of the Emissions (1000 metric ton of CO2 equivalent) of 2005 in Belarus to that in Belgium?
Provide a succinct answer. 2.93. What is the ratio of the Emissions (1000 metric ton of CO2 equivalent) in 2008 in Belarus to that in Belgium?
Your answer should be compact. 3.18. What is the ratio of the Emissions (1000 metric ton of CO2 equivalent) in 1990 in Belarus to that in Benin?
Provide a short and direct response. 6.92. What is the ratio of the Emissions (1000 metric ton of CO2 equivalent) in 2000 in Belarus to that in Benin?
Give a very brief answer. 4.13. What is the ratio of the Emissions (1000 metric ton of CO2 equivalent) of 2005 in Belarus to that in Benin?
Your answer should be very brief. 4.84. What is the ratio of the Emissions (1000 metric ton of CO2 equivalent) in 2008 in Belarus to that in Benin?
Make the answer very short. 2.77. What is the ratio of the Emissions (1000 metric ton of CO2 equivalent) of 1990 in Belgium to that in Benin?
Offer a terse response. 1.83. What is the ratio of the Emissions (1000 metric ton of CO2 equivalent) in 2000 in Belgium to that in Benin?
Give a very brief answer. 1.61. What is the ratio of the Emissions (1000 metric ton of CO2 equivalent) in 2005 in Belgium to that in Benin?
Your answer should be very brief. 1.66. What is the ratio of the Emissions (1000 metric ton of CO2 equivalent) of 2008 in Belgium to that in Benin?
Make the answer very short. 0.87. What is the difference between the highest and the second highest Emissions (1000 metric ton of CO2 equivalent) of 1990?
Your answer should be compact. 308.3. What is the difference between the highest and the second highest Emissions (1000 metric ton of CO2 equivalent) in 2000?
Offer a terse response. 8176.2. What is the difference between the highest and the second highest Emissions (1000 metric ton of CO2 equivalent) in 2005?
Your answer should be compact. 9263.9. What is the difference between the highest and the second highest Emissions (1000 metric ton of CO2 equivalent) in 2008?
Provide a short and direct response. 9584.1. What is the difference between the highest and the lowest Emissions (1000 metric ton of CO2 equivalent) of 1990?
Provide a succinct answer. 1.25e+04. What is the difference between the highest and the lowest Emissions (1000 metric ton of CO2 equivalent) of 2000?
Offer a very short reply. 1.62e+04. What is the difference between the highest and the lowest Emissions (1000 metric ton of CO2 equivalent) in 2005?
Provide a short and direct response. 1.78e+04. What is the difference between the highest and the lowest Emissions (1000 metric ton of CO2 equivalent) in 2008?
Provide a short and direct response. 1.85e+04. 